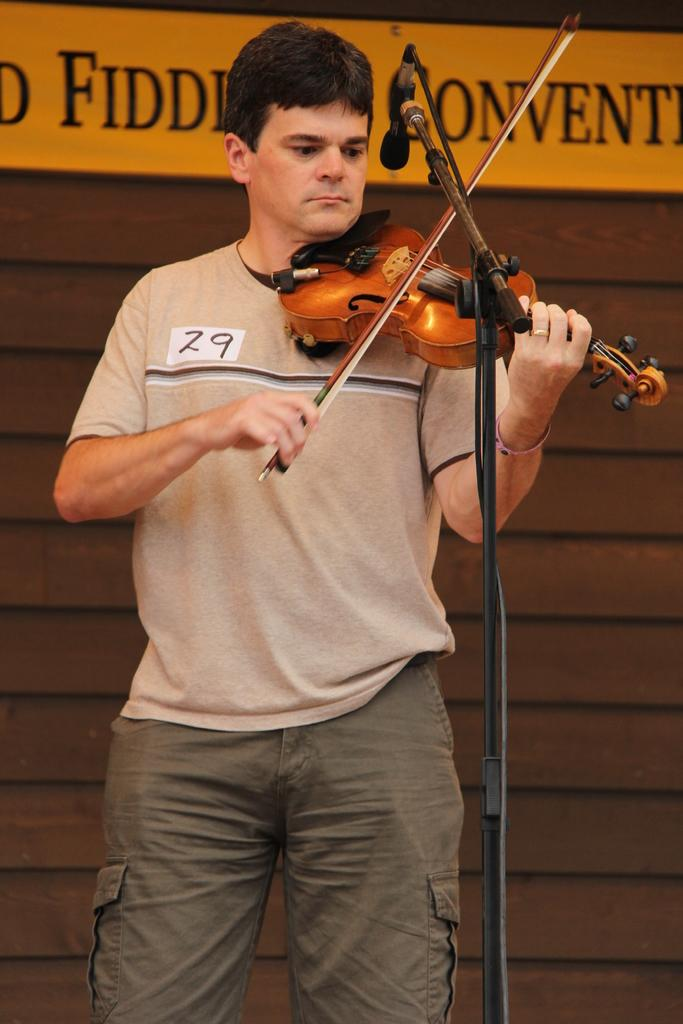What is the person in the image doing? The person is playing a violin. What can be seen near the person in the image? The person is standing in front of a microphone. What is the color of the background in the image? The background of the image is brown. What is written on the yellow board in the background? Unfortunately, we cannot determine what is written on the yellow board in the image. What type of veil is the person wearing in the image? There is no veil present in the image. 